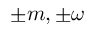<formula> <loc_0><loc_0><loc_500><loc_500>\pm m , \pm \omega</formula> 